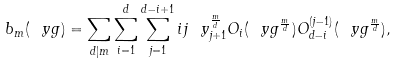Convert formula to latex. <formula><loc_0><loc_0><loc_500><loc_500>b _ { m } ( \ y g ) = \sum _ { d | m } \sum _ { i = 1 } ^ { d } \sum _ { j = 1 } ^ { d - i + 1 } i j \ y _ { j + 1 } ^ { \frac { m } { d } } O _ { i } ( \ y g ^ { \frac { m } { d } } ) O _ { d - i } ^ { ( j - 1 ) } ( \ y g ^ { \frac { m } { d } } ) ,</formula> 